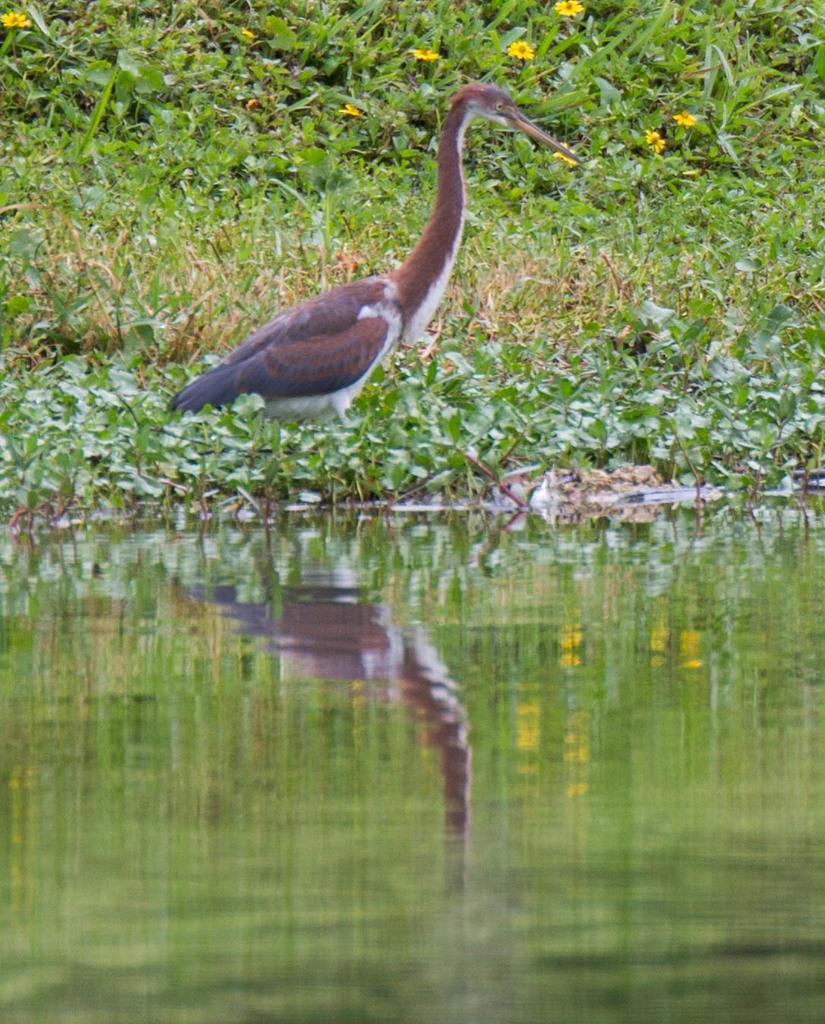In one or two sentences, can you explain what this image depicts? This picture is clicked outside. In the foreground we can see a water body. In the center there is a bird seems to be standing on the ground and we can see the plants and flowers in the background. 